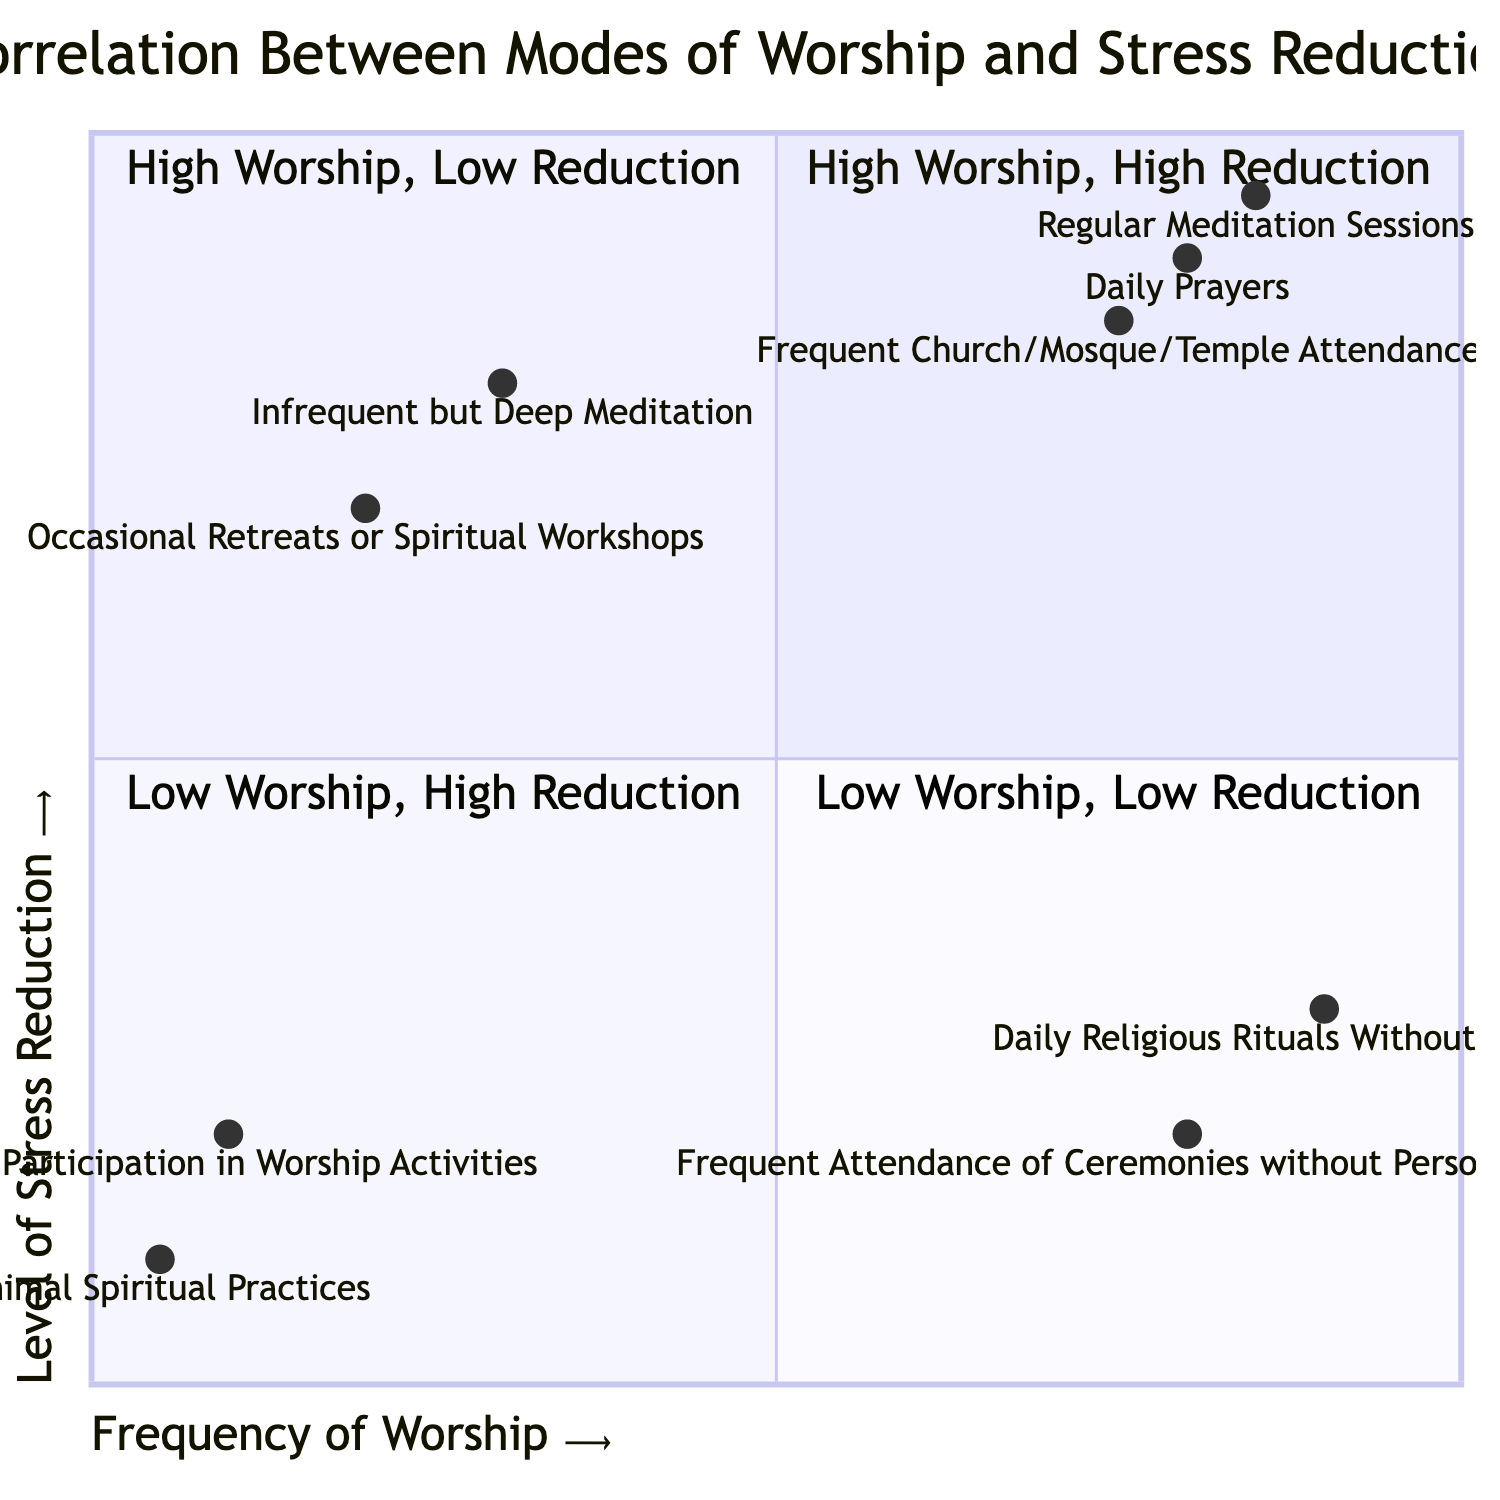What are the nodes in Quadrant 1? Quadrant 1 contains entries that indicate both high frequency of worship and high levels of stress reduction. By looking at the quadrant, we find the nodes listed are Daily Prayers, Regular Meditation Sessions, and Frequent Church/Mosque/Temple Attendance.
Answer: Daily Prayers, Regular Meditation Sessions, Frequent Church/Mosque/Temple Attendance How many nodes are in Quadrant 2? Quadrant 2 lists modes of worship that have high activity levels but low stress reduction. Counting the entries, there are two nodes: Daily Religious Rituals Without Meditation and Frequent Attendance of Ceremonies without Personal Reflection.
Answer: 2 Which mode of worship has the highest level of stress reduction in Quadrant 1? In Quadrant 1, we can see that Regular Meditation Sessions has the highest y-value (0.95) which indicates the highest level of stress reduction compared to the other nodes in that quadrant.
Answer: Regular Meditation Sessions In which quadrant does "Infrequent but Deep Meditation" belong? The entry "Infrequent but Deep Meditation" is located in Quadrant 3 as it indicates a low frequency of worship combined with a high level of stress reduction. This matches the characteristics of Quadrant 3.
Answer: Quadrant 3 What is the stress reduction level for "Minimal Spiritual Practices"? By checking the data for the node "Minimal Spiritual Practices," we find that its corresponding y-value (stress reduction level) is 0.1, which is indicated in Quadrant 4.
Answer: 0.1 How does the frequency of worship for "Frequent Attendance of Ceremonies without Personal Reflection" compare to "Rare Participation in Worship Activities"? "Frequent Attendance of Ceremonies without Personal Reflection" has a frequency value of 0.8 while "Rare Participation in Worship Activities" has a frequency value of 0.1. Therefore, there is a significant difference with the former being higher than the latter.
Answer: Higher What is the number of modes of worship that have low stress reduction? Low stress reduction is characterized by y-values below 0.5, and by inspecting all quadrants, we find four nodes that meet this criterion: Daily Religious Rituals Without Meditation, Frequent Attendance of Ceremonies without Personal Reflection, Rare Participation in Worship Activities, and Minimal Spiritual Practices. Thus, there are four nodes.
Answer: 4 Which quadrant has only one mode of worship? By examining the quadrants, Quadrant 4 displays two entries, but Quadrant 3 contains only one entry, which is "Infrequent but Deep Meditation." Hence, it is identified as the quadrant that has only one mode of worship.
Answer: Quadrant 3 What is the frequency of worship for "Regular Meditation Sessions"? In the data provided, "Regular Meditation Sessions" has a frequency value of 0.85. This value can be directly obtained from the identified Quadrant 1 where this node is located.
Answer: 0.85 